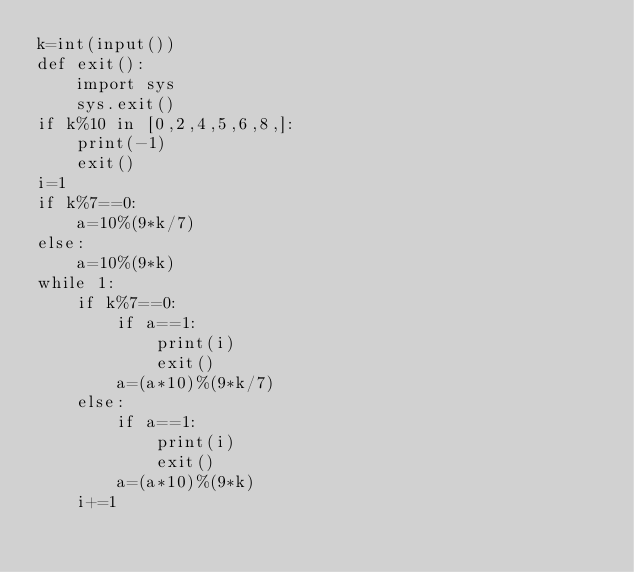<code> <loc_0><loc_0><loc_500><loc_500><_Python_>k=int(input())
def exit():
    import sys
    sys.exit()
if k%10 in [0,2,4,5,6,8,]:
    print(-1)
    exit()
i=1
if k%7==0:
    a=10%(9*k/7)
else:
    a=10%(9*k)
while 1:
    if k%7==0:
        if a==1:
            print(i)
            exit()
        a=(a*10)%(9*k/7)
    else:
        if a==1:
            print(i)
            exit()
        a=(a*10)%(9*k)
    i+=1</code> 